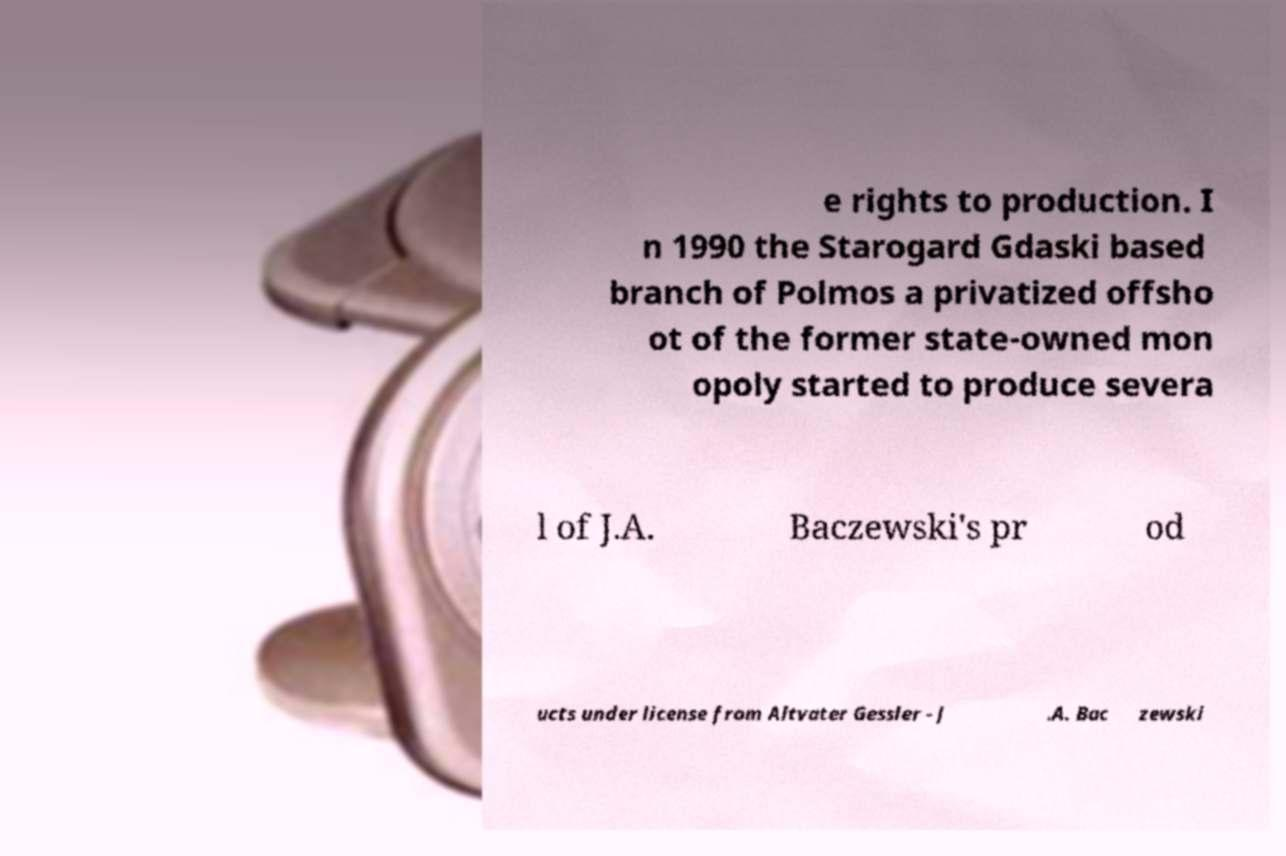Can you accurately transcribe the text from the provided image for me? e rights to production. I n 1990 the Starogard Gdaski based branch of Polmos a privatized offsho ot of the former state-owned mon opoly started to produce severa l of J.A. Baczewski's pr od ucts under license from Altvater Gessler - J .A. Bac zewski 